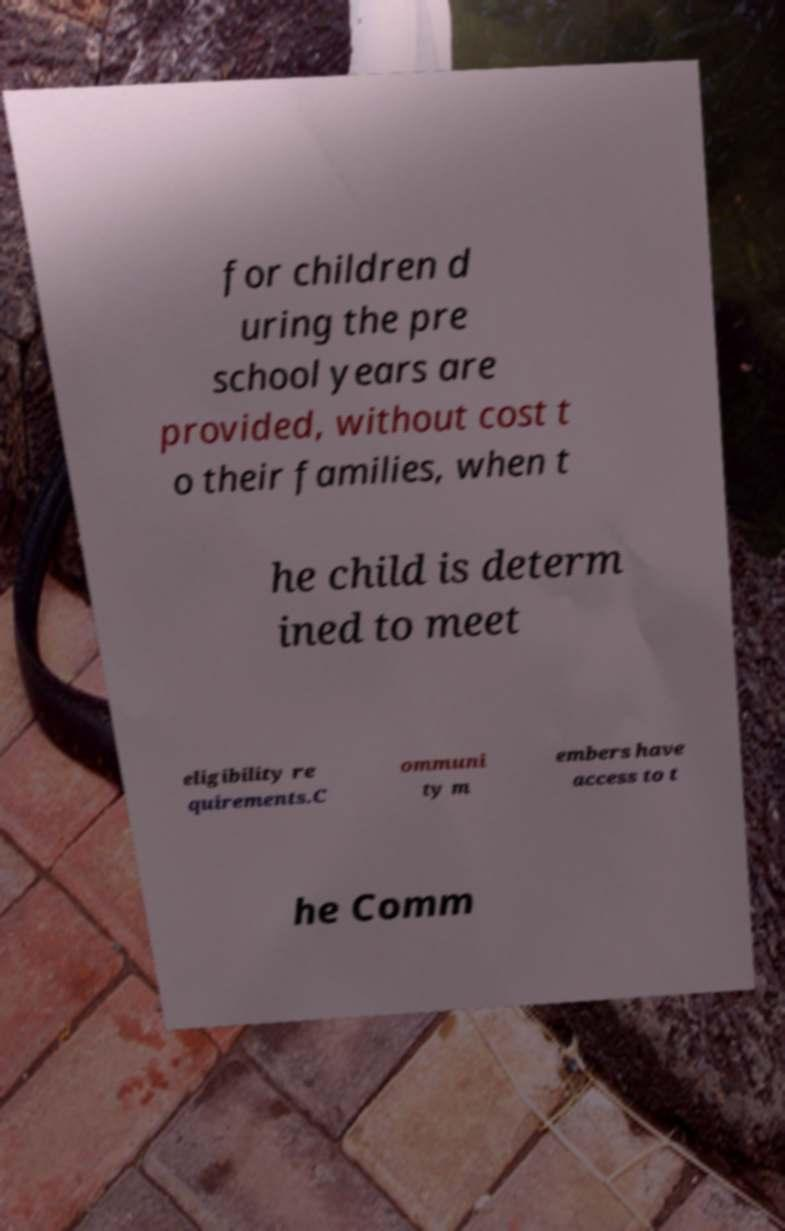For documentation purposes, I need the text within this image transcribed. Could you provide that? for children d uring the pre school years are provided, without cost t o their families, when t he child is determ ined to meet eligibility re quirements.C ommuni ty m embers have access to t he Comm 